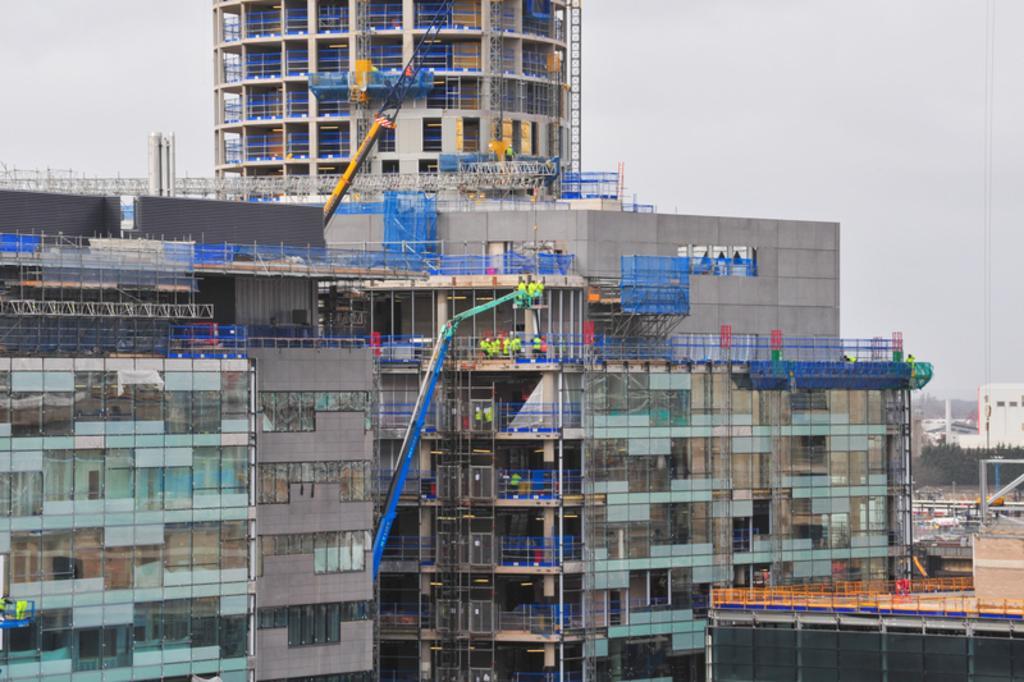Could you give a brief overview of what you see in this image? In this picture we can see buildings, cranes, fences, trees, some objects and some people and in the background we can see the sky. 